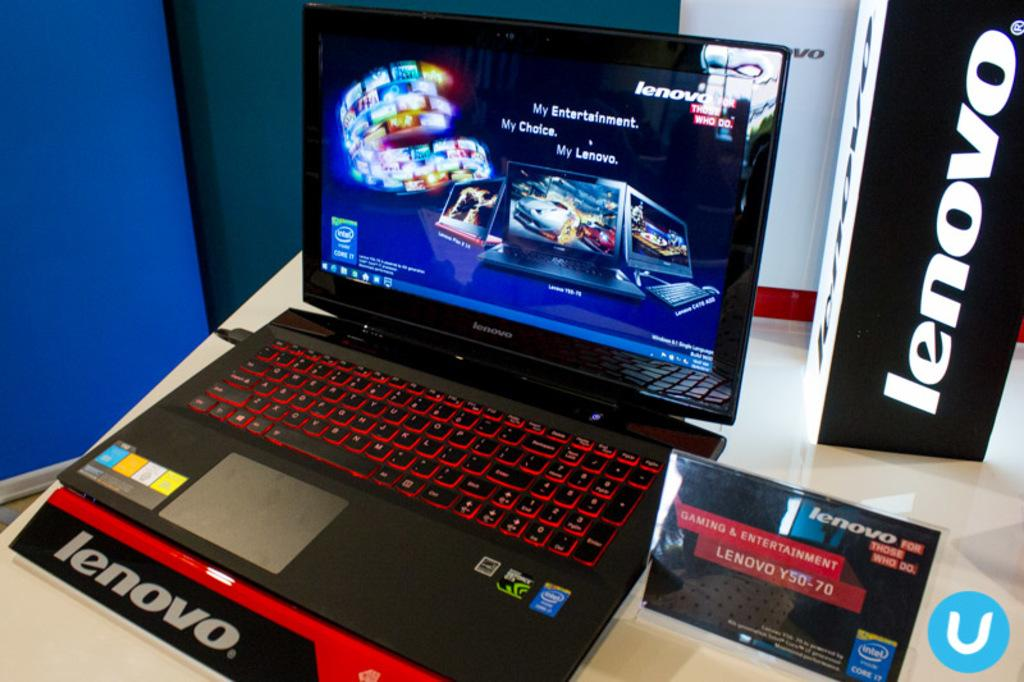<image>
Relay a brief, clear account of the picture shown. A view of a lenovo laptop with a red back lit keyboard 